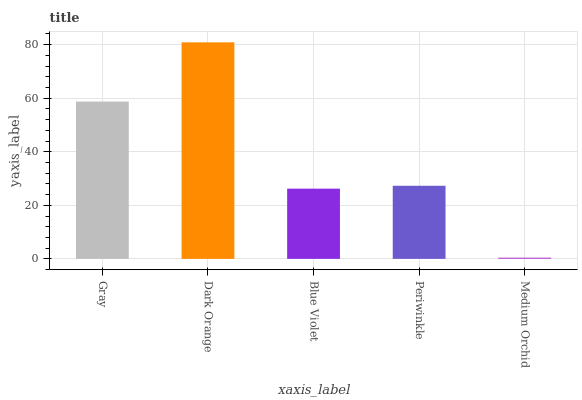Is Medium Orchid the minimum?
Answer yes or no. Yes. Is Dark Orange the maximum?
Answer yes or no. Yes. Is Blue Violet the minimum?
Answer yes or no. No. Is Blue Violet the maximum?
Answer yes or no. No. Is Dark Orange greater than Blue Violet?
Answer yes or no. Yes. Is Blue Violet less than Dark Orange?
Answer yes or no. Yes. Is Blue Violet greater than Dark Orange?
Answer yes or no. No. Is Dark Orange less than Blue Violet?
Answer yes or no. No. Is Periwinkle the high median?
Answer yes or no. Yes. Is Periwinkle the low median?
Answer yes or no. Yes. Is Medium Orchid the high median?
Answer yes or no. No. Is Blue Violet the low median?
Answer yes or no. No. 